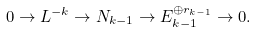<formula> <loc_0><loc_0><loc_500><loc_500>0 \to L ^ { - k } \to N _ { k - 1 } \to E _ { k - 1 } ^ { \oplus r _ { k - 1 } } \to 0 .</formula> 